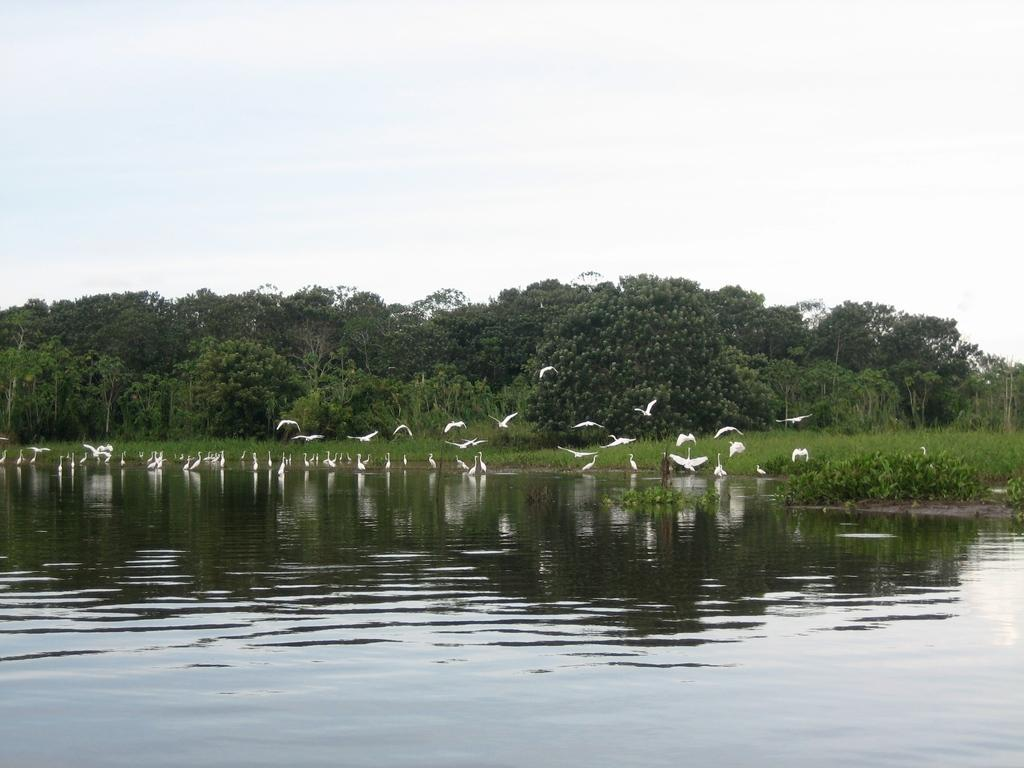What is located at the bottom of the image? There is a river at the bottom of the image. What can be seen near the river? There are birds near the river. What type of vegetation is visible in the background of the image? There are trees in the background of the image. What else can be seen in the background of the image? The sky is visible in the background of the image. What type of bone can be seen sticking out of the river in the image? There is no bone present in the image; it features a river with birds near it and trees and sky in the background. 